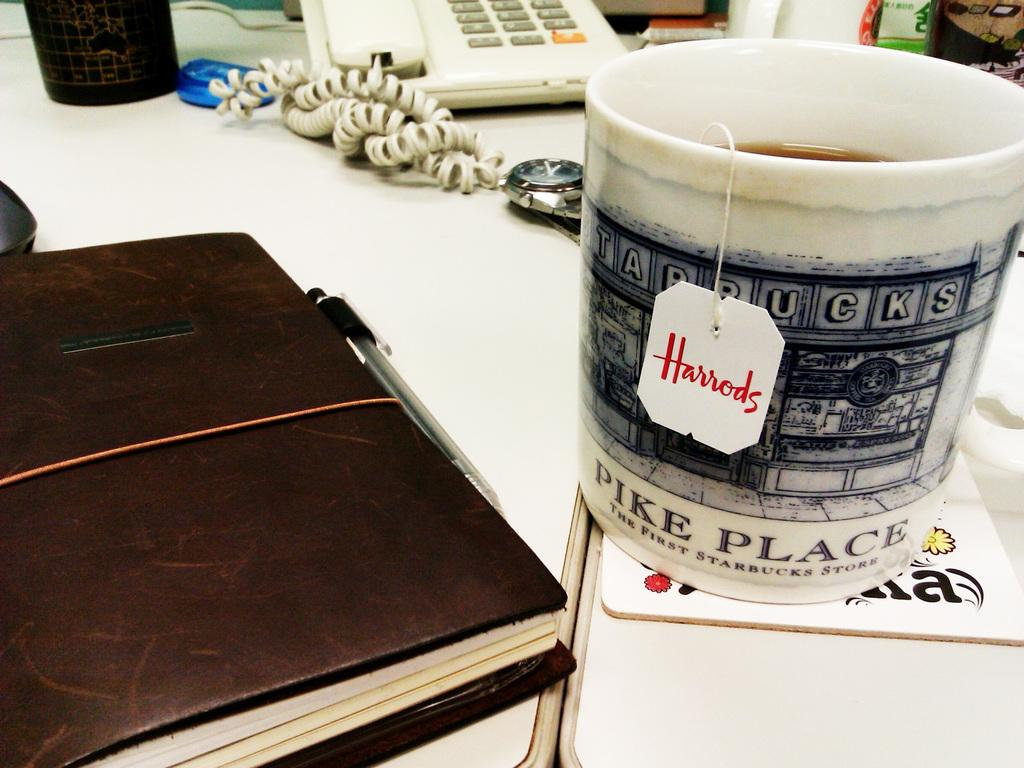<image>
Describe the image concisely. A mug with Pike Place written on the front is steeping some Harrods Tea 